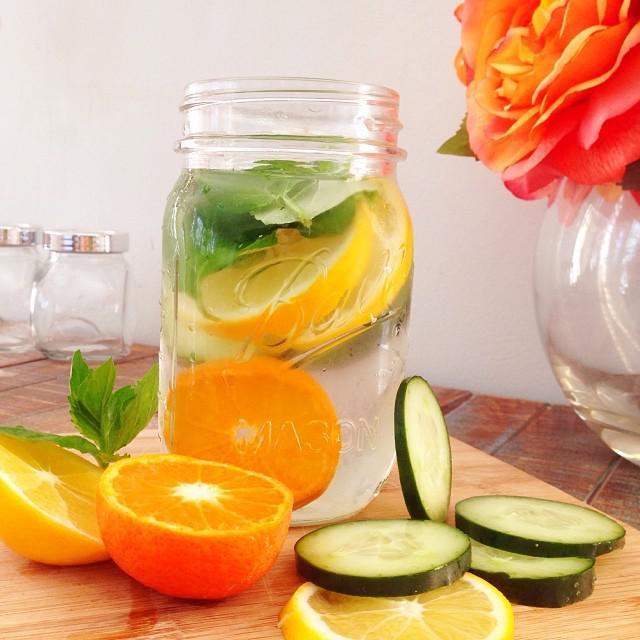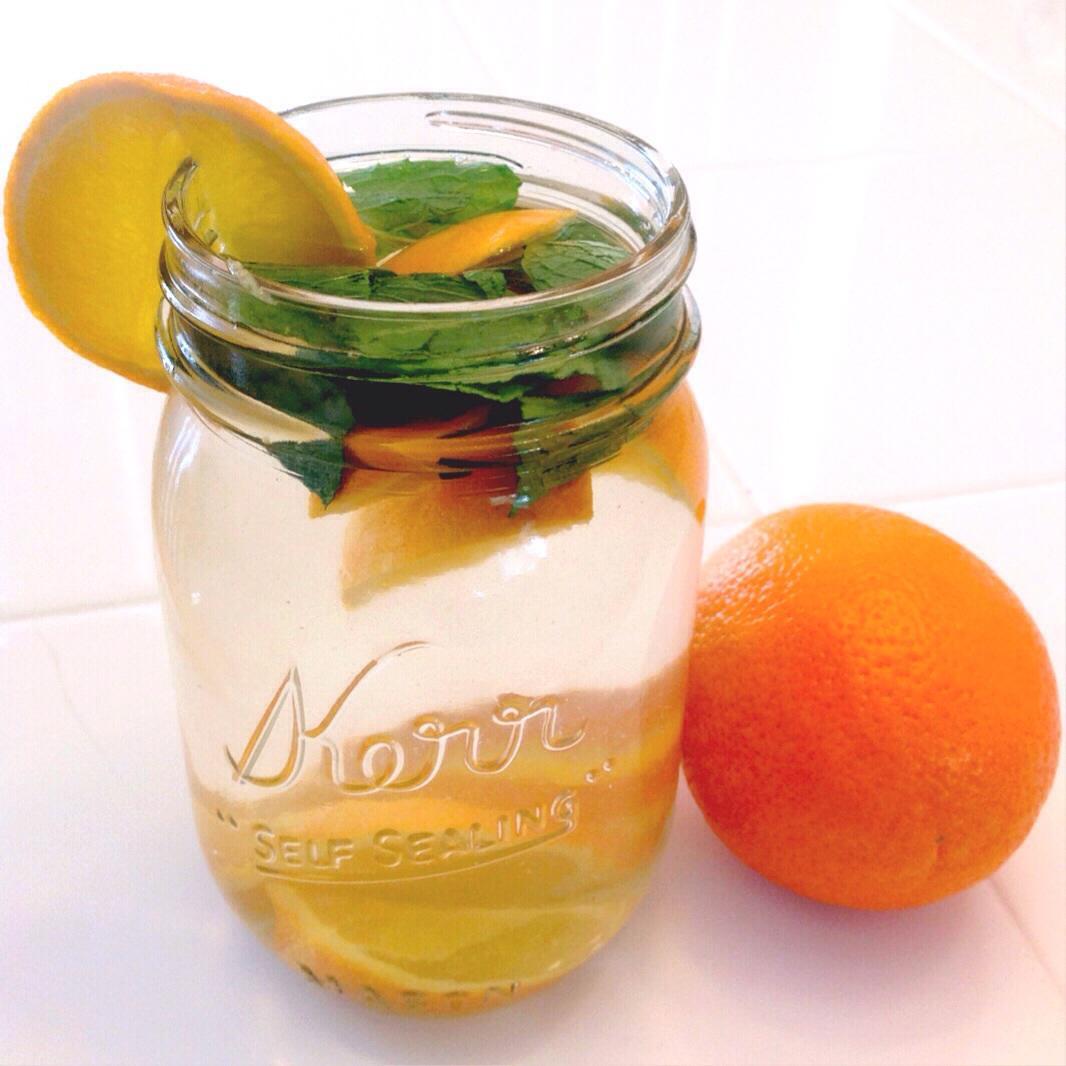The first image is the image on the left, the second image is the image on the right. Assess this claim about the two images: "An image shows a striped straw in a jar-type beverage glass.". Correct or not? Answer yes or no. No. The first image is the image on the left, the second image is the image on the right. Given the left and right images, does the statement "In one image, drinks are served in two mason jar glasses, one of them sitting on a cloth napkin, with striped straws." hold true? Answer yes or no. No. 